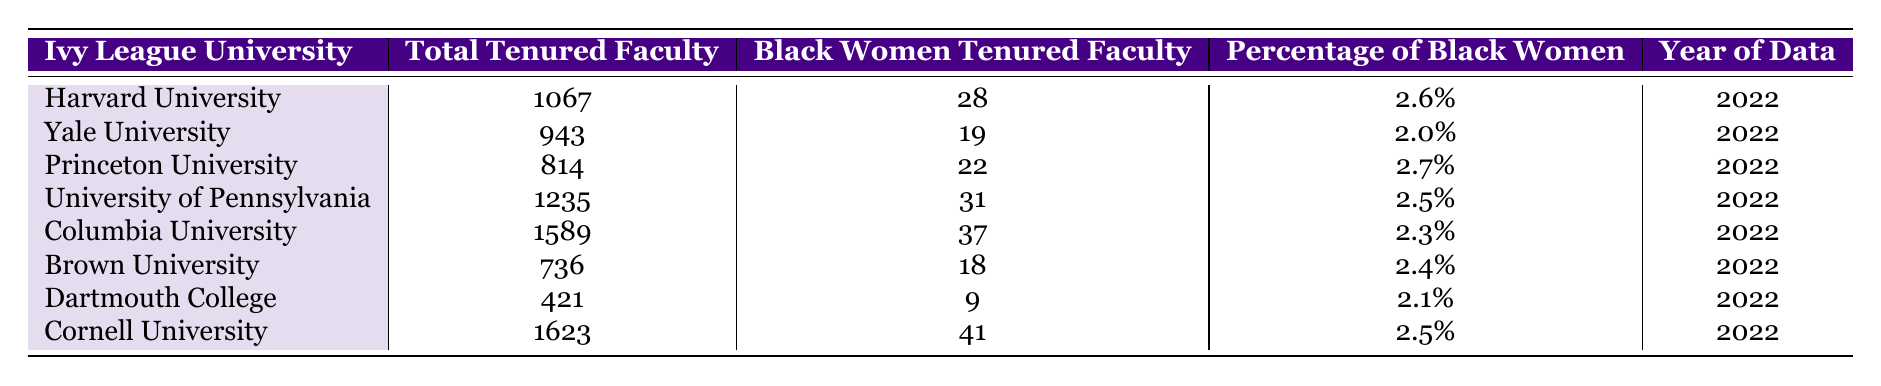What is the total number of tenured faculty at Harvard University? The table shows the total tenured faculty for each university. For Harvard University, the value listed is 1067.
Answer: 1067 What percentage of tenured faculty at Brown University are Black women? According to the table, Brown University has 2.4% of its tenured faculty as Black women.
Answer: 2.4% Which Ivy League university has the highest number of Black women tenured faculty? By comparing the values in the "Black Women Tenured Faculty" column, Cornell University has the highest number with 41.
Answer: Cornell University Is the percentage of Black women in tenured positions at Yale University above or below 2.5%? Yale University's percentage of Black women tenured faculty is 2.0%, which is below 2.5%.
Answer: Below What is the average percentage of Black women tenured faculty across all Ivy League universities listed? First, sum the percentages: 2.6 + 2.0 + 2.7 + 2.5 + 2.3 + 2.4 + 2.1 + 2.5 = 18.1. Then divide by 8 (the number of universities) to find the average: 18.1 / 8 = 2.2625%, which rounds to 2.26%.
Answer: 2.26% How many total tenured faculty positions are there among the eight Ivy League universities listed? To find the total, sum all values in the "Total Tenured Faculty" column: 1067 + 943 + 814 + 1235 + 1589 + 736 + 421 + 1623 = 5938.
Answer: 5938 What is the difference in the number of Black women tenured faculty between Princeton University and Dartmouth College? Princeton has 22 Black women tenured faculty while Dartmouth has 9. The difference is 22 - 9 = 13.
Answer: 13 Which Ivy League university has the lowest percentage of Black women tenured faculty, and what is that percentage? By reviewing the "Percentage of Black Women" column, the lowest percentage is 2.0% at Yale University.
Answer: Yale University, 2.0% If you combine the number of Black women tenured faculty from Harvard and Cornell, how many would that be? Adding Harvard's 28 and Cornell's 41 gives 28 + 41 = 69.
Answer: 69 